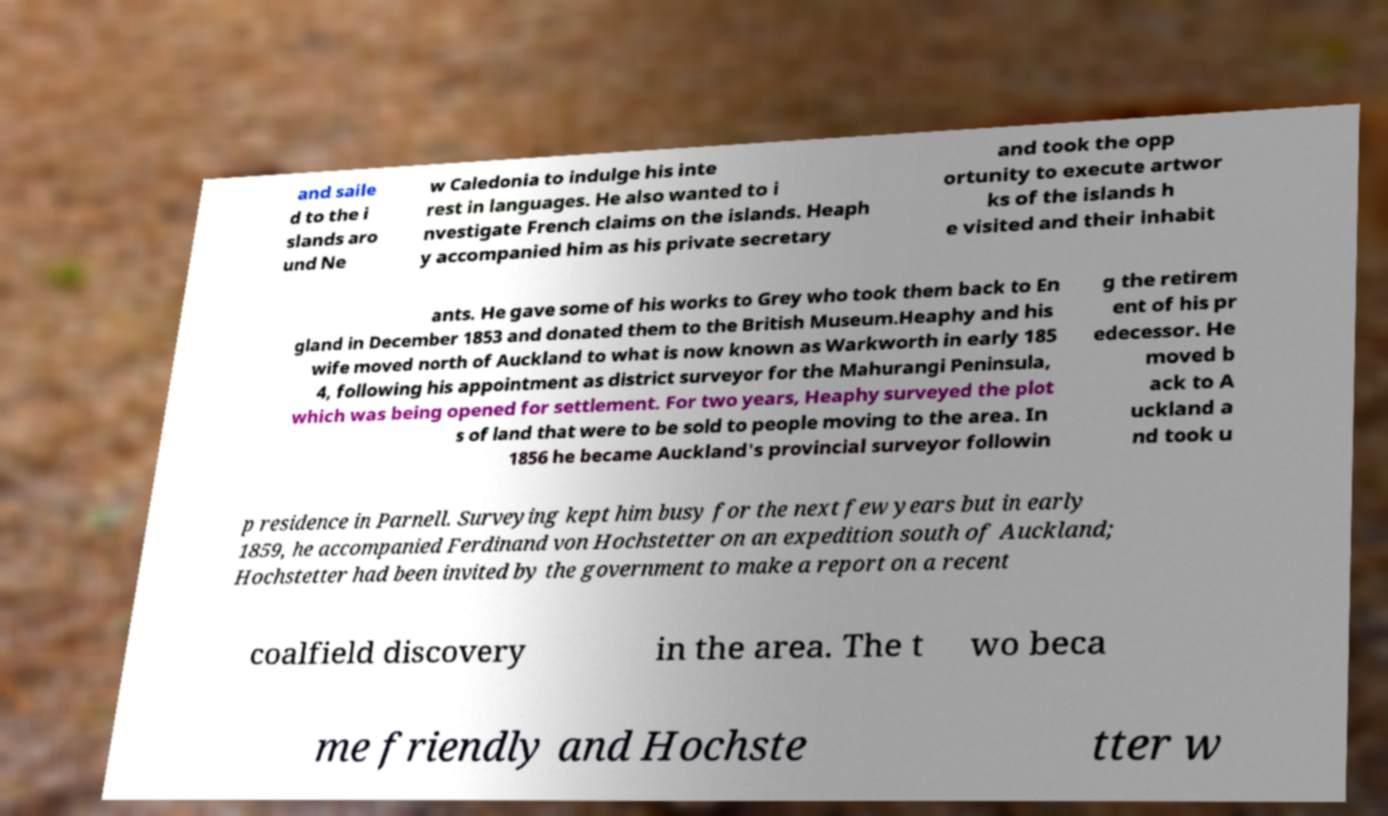I need the written content from this picture converted into text. Can you do that? and saile d to the i slands aro und Ne w Caledonia to indulge his inte rest in languages. He also wanted to i nvestigate French claims on the islands. Heaph y accompanied him as his private secretary and took the opp ortunity to execute artwor ks of the islands h e visited and their inhabit ants. He gave some of his works to Grey who took them back to En gland in December 1853 and donated them to the British Museum.Heaphy and his wife moved north of Auckland to what is now known as Warkworth in early 185 4, following his appointment as district surveyor for the Mahurangi Peninsula, which was being opened for settlement. For two years, Heaphy surveyed the plot s of land that were to be sold to people moving to the area. In 1856 he became Auckland's provincial surveyor followin g the retirem ent of his pr edecessor. He moved b ack to A uckland a nd took u p residence in Parnell. Surveying kept him busy for the next few years but in early 1859, he accompanied Ferdinand von Hochstetter on an expedition south of Auckland; Hochstetter had been invited by the government to make a report on a recent coalfield discovery in the area. The t wo beca me friendly and Hochste tter w 